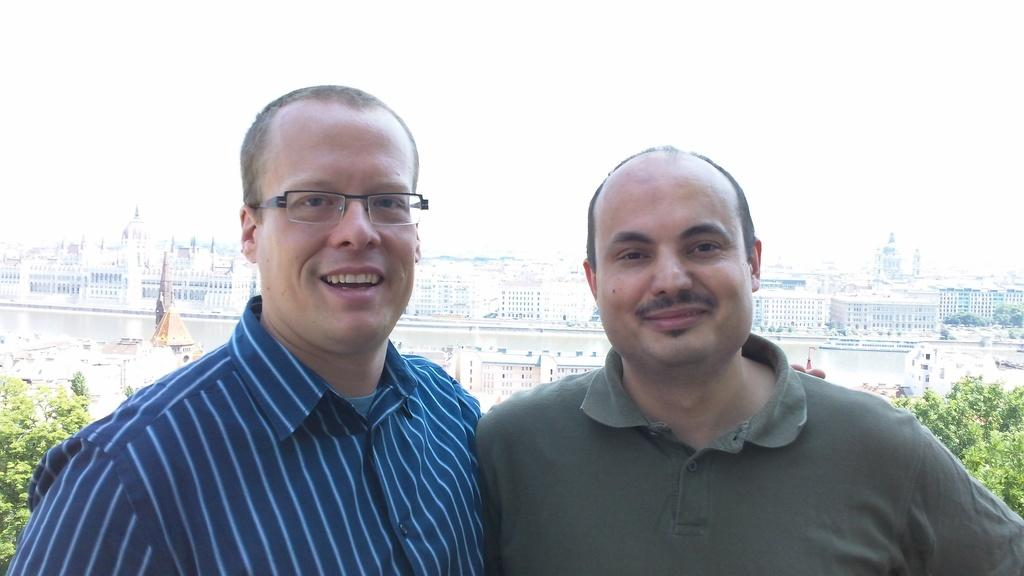What is the person in the foreground of the image wearing? The person in the foreground of the image is wearing a shirt and spectacles. What is the facial expression of the person in the foreground? The person in the foreground is smiling. What is the second person in the image wearing? The second person in the image is wearing a T-shirt. What is the facial expression of the second person? The second person is also smiling. What can be seen in the background of the image? There are trees, buildings, and water visible in the background of the image. What part of the natural environment is visible in the image? The sky is visible in the image. What type of sign can be seen on the trail in the image? There is no trail or sign present in the image. 